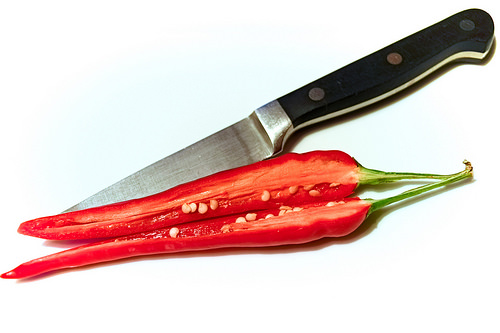<image>
Is the chilli on the knife? Yes. Looking at the image, I can see the chilli is positioned on top of the knife, with the knife providing support. 